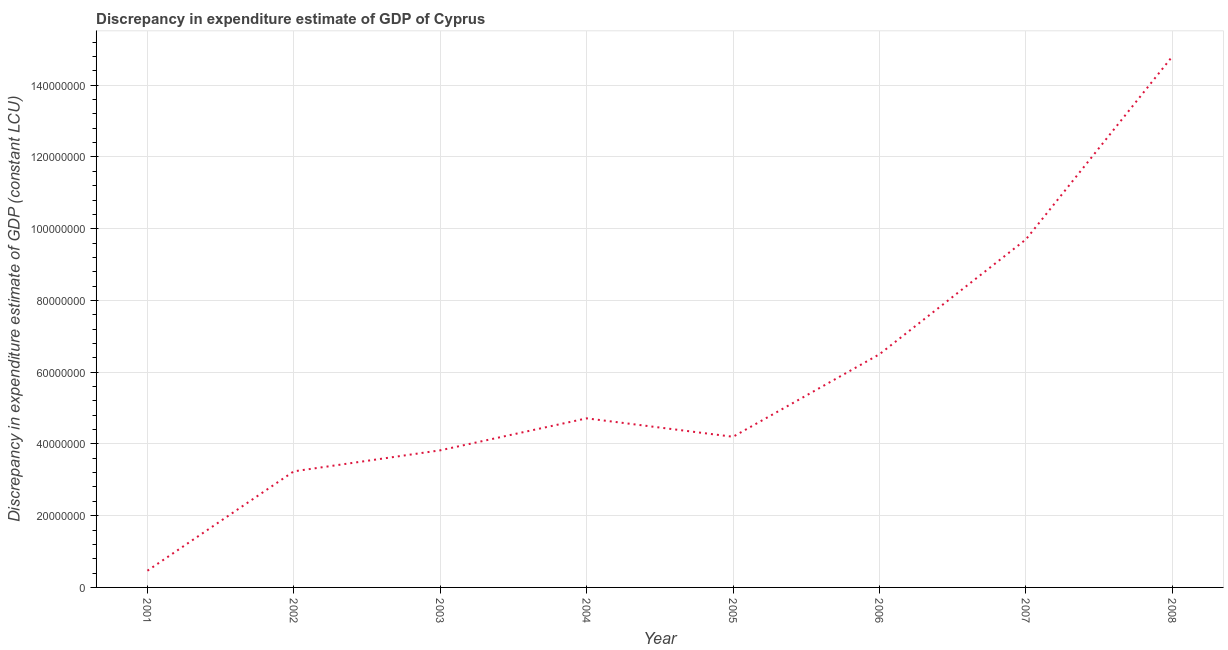What is the discrepancy in expenditure estimate of gdp in 2007?
Provide a succinct answer. 9.70e+07. Across all years, what is the maximum discrepancy in expenditure estimate of gdp?
Ensure brevity in your answer.  1.48e+08. Across all years, what is the minimum discrepancy in expenditure estimate of gdp?
Make the answer very short. 4.66e+06. What is the sum of the discrepancy in expenditure estimate of gdp?
Provide a short and direct response. 4.74e+08. What is the difference between the discrepancy in expenditure estimate of gdp in 2006 and 2007?
Provide a short and direct response. -3.20e+07. What is the average discrepancy in expenditure estimate of gdp per year?
Your response must be concise. 5.93e+07. What is the median discrepancy in expenditure estimate of gdp?
Your answer should be very brief. 4.46e+07. Do a majority of the years between 2006 and 2003 (inclusive) have discrepancy in expenditure estimate of gdp greater than 120000000 LCU?
Offer a very short reply. Yes. What is the ratio of the discrepancy in expenditure estimate of gdp in 2002 to that in 2008?
Your answer should be very brief. 0.22. Is the discrepancy in expenditure estimate of gdp in 2001 less than that in 2002?
Ensure brevity in your answer.  Yes. Is the difference between the discrepancy in expenditure estimate of gdp in 2002 and 2007 greater than the difference between any two years?
Keep it short and to the point. No. What is the difference between the highest and the second highest discrepancy in expenditure estimate of gdp?
Keep it short and to the point. 5.10e+07. Is the sum of the discrepancy in expenditure estimate of gdp in 2001 and 2006 greater than the maximum discrepancy in expenditure estimate of gdp across all years?
Ensure brevity in your answer.  No. What is the difference between the highest and the lowest discrepancy in expenditure estimate of gdp?
Keep it short and to the point. 1.43e+08. In how many years, is the discrepancy in expenditure estimate of gdp greater than the average discrepancy in expenditure estimate of gdp taken over all years?
Make the answer very short. 3. Does the discrepancy in expenditure estimate of gdp monotonically increase over the years?
Your answer should be compact. No. How many lines are there?
Your response must be concise. 1. How many years are there in the graph?
Provide a succinct answer. 8. What is the difference between two consecutive major ticks on the Y-axis?
Your response must be concise. 2.00e+07. Does the graph contain any zero values?
Ensure brevity in your answer.  No. What is the title of the graph?
Your response must be concise. Discrepancy in expenditure estimate of GDP of Cyprus. What is the label or title of the Y-axis?
Provide a short and direct response. Discrepancy in expenditure estimate of GDP (constant LCU). What is the Discrepancy in expenditure estimate of GDP (constant LCU) of 2001?
Your answer should be very brief. 4.66e+06. What is the Discrepancy in expenditure estimate of GDP (constant LCU) of 2002?
Offer a terse response. 3.24e+07. What is the Discrepancy in expenditure estimate of GDP (constant LCU) in 2003?
Provide a succinct answer. 3.82e+07. What is the Discrepancy in expenditure estimate of GDP (constant LCU) of 2004?
Your answer should be very brief. 4.71e+07. What is the Discrepancy in expenditure estimate of GDP (constant LCU) of 2005?
Offer a very short reply. 4.20e+07. What is the Discrepancy in expenditure estimate of GDP (constant LCU) in 2006?
Your answer should be very brief. 6.50e+07. What is the Discrepancy in expenditure estimate of GDP (constant LCU) of 2007?
Make the answer very short. 9.70e+07. What is the Discrepancy in expenditure estimate of GDP (constant LCU) in 2008?
Provide a succinct answer. 1.48e+08. What is the difference between the Discrepancy in expenditure estimate of GDP (constant LCU) in 2001 and 2002?
Your response must be concise. -2.77e+07. What is the difference between the Discrepancy in expenditure estimate of GDP (constant LCU) in 2001 and 2003?
Keep it short and to the point. -3.36e+07. What is the difference between the Discrepancy in expenditure estimate of GDP (constant LCU) in 2001 and 2004?
Give a very brief answer. -4.25e+07. What is the difference between the Discrepancy in expenditure estimate of GDP (constant LCU) in 2001 and 2005?
Ensure brevity in your answer.  -3.73e+07. What is the difference between the Discrepancy in expenditure estimate of GDP (constant LCU) in 2001 and 2006?
Offer a terse response. -6.03e+07. What is the difference between the Discrepancy in expenditure estimate of GDP (constant LCU) in 2001 and 2007?
Make the answer very short. -9.23e+07. What is the difference between the Discrepancy in expenditure estimate of GDP (constant LCU) in 2001 and 2008?
Offer a terse response. -1.43e+08. What is the difference between the Discrepancy in expenditure estimate of GDP (constant LCU) in 2002 and 2003?
Your answer should be very brief. -5.86e+06. What is the difference between the Discrepancy in expenditure estimate of GDP (constant LCU) in 2002 and 2004?
Your answer should be very brief. -1.48e+07. What is the difference between the Discrepancy in expenditure estimate of GDP (constant LCU) in 2002 and 2005?
Keep it short and to the point. -9.63e+06. What is the difference between the Discrepancy in expenditure estimate of GDP (constant LCU) in 2002 and 2006?
Offer a very short reply. -3.26e+07. What is the difference between the Discrepancy in expenditure estimate of GDP (constant LCU) in 2002 and 2007?
Your response must be concise. -6.46e+07. What is the difference between the Discrepancy in expenditure estimate of GDP (constant LCU) in 2002 and 2008?
Your answer should be very brief. -1.16e+08. What is the difference between the Discrepancy in expenditure estimate of GDP (constant LCU) in 2003 and 2004?
Your answer should be compact. -8.91e+06. What is the difference between the Discrepancy in expenditure estimate of GDP (constant LCU) in 2003 and 2005?
Ensure brevity in your answer.  -3.78e+06. What is the difference between the Discrepancy in expenditure estimate of GDP (constant LCU) in 2003 and 2006?
Offer a terse response. -2.68e+07. What is the difference between the Discrepancy in expenditure estimate of GDP (constant LCU) in 2003 and 2007?
Your answer should be very brief. -5.88e+07. What is the difference between the Discrepancy in expenditure estimate of GDP (constant LCU) in 2003 and 2008?
Ensure brevity in your answer.  -1.10e+08. What is the difference between the Discrepancy in expenditure estimate of GDP (constant LCU) in 2004 and 2005?
Provide a short and direct response. 5.14e+06. What is the difference between the Discrepancy in expenditure estimate of GDP (constant LCU) in 2004 and 2006?
Make the answer very short. -1.79e+07. What is the difference between the Discrepancy in expenditure estimate of GDP (constant LCU) in 2004 and 2007?
Give a very brief answer. -4.99e+07. What is the difference between the Discrepancy in expenditure estimate of GDP (constant LCU) in 2004 and 2008?
Make the answer very short. -1.01e+08. What is the difference between the Discrepancy in expenditure estimate of GDP (constant LCU) in 2005 and 2006?
Provide a succinct answer. -2.30e+07. What is the difference between the Discrepancy in expenditure estimate of GDP (constant LCU) in 2005 and 2007?
Keep it short and to the point. -5.50e+07. What is the difference between the Discrepancy in expenditure estimate of GDP (constant LCU) in 2005 and 2008?
Your answer should be very brief. -1.06e+08. What is the difference between the Discrepancy in expenditure estimate of GDP (constant LCU) in 2006 and 2007?
Ensure brevity in your answer.  -3.20e+07. What is the difference between the Discrepancy in expenditure estimate of GDP (constant LCU) in 2006 and 2008?
Your answer should be very brief. -8.30e+07. What is the difference between the Discrepancy in expenditure estimate of GDP (constant LCU) in 2007 and 2008?
Ensure brevity in your answer.  -5.10e+07. What is the ratio of the Discrepancy in expenditure estimate of GDP (constant LCU) in 2001 to that in 2002?
Provide a short and direct response. 0.14. What is the ratio of the Discrepancy in expenditure estimate of GDP (constant LCU) in 2001 to that in 2003?
Your answer should be very brief. 0.12. What is the ratio of the Discrepancy in expenditure estimate of GDP (constant LCU) in 2001 to that in 2004?
Your answer should be compact. 0.1. What is the ratio of the Discrepancy in expenditure estimate of GDP (constant LCU) in 2001 to that in 2005?
Give a very brief answer. 0.11. What is the ratio of the Discrepancy in expenditure estimate of GDP (constant LCU) in 2001 to that in 2006?
Your response must be concise. 0.07. What is the ratio of the Discrepancy in expenditure estimate of GDP (constant LCU) in 2001 to that in 2007?
Ensure brevity in your answer.  0.05. What is the ratio of the Discrepancy in expenditure estimate of GDP (constant LCU) in 2001 to that in 2008?
Make the answer very short. 0.03. What is the ratio of the Discrepancy in expenditure estimate of GDP (constant LCU) in 2002 to that in 2003?
Make the answer very short. 0.85. What is the ratio of the Discrepancy in expenditure estimate of GDP (constant LCU) in 2002 to that in 2004?
Give a very brief answer. 0.69. What is the ratio of the Discrepancy in expenditure estimate of GDP (constant LCU) in 2002 to that in 2005?
Provide a short and direct response. 0.77. What is the ratio of the Discrepancy in expenditure estimate of GDP (constant LCU) in 2002 to that in 2006?
Provide a short and direct response. 0.5. What is the ratio of the Discrepancy in expenditure estimate of GDP (constant LCU) in 2002 to that in 2007?
Ensure brevity in your answer.  0.33. What is the ratio of the Discrepancy in expenditure estimate of GDP (constant LCU) in 2002 to that in 2008?
Your answer should be very brief. 0.22. What is the ratio of the Discrepancy in expenditure estimate of GDP (constant LCU) in 2003 to that in 2004?
Ensure brevity in your answer.  0.81. What is the ratio of the Discrepancy in expenditure estimate of GDP (constant LCU) in 2003 to that in 2005?
Offer a very short reply. 0.91. What is the ratio of the Discrepancy in expenditure estimate of GDP (constant LCU) in 2003 to that in 2006?
Offer a very short reply. 0.59. What is the ratio of the Discrepancy in expenditure estimate of GDP (constant LCU) in 2003 to that in 2007?
Provide a short and direct response. 0.39. What is the ratio of the Discrepancy in expenditure estimate of GDP (constant LCU) in 2003 to that in 2008?
Make the answer very short. 0.26. What is the ratio of the Discrepancy in expenditure estimate of GDP (constant LCU) in 2004 to that in 2005?
Offer a very short reply. 1.12. What is the ratio of the Discrepancy in expenditure estimate of GDP (constant LCU) in 2004 to that in 2006?
Ensure brevity in your answer.  0.72. What is the ratio of the Discrepancy in expenditure estimate of GDP (constant LCU) in 2004 to that in 2007?
Provide a short and direct response. 0.49. What is the ratio of the Discrepancy in expenditure estimate of GDP (constant LCU) in 2004 to that in 2008?
Provide a succinct answer. 0.32. What is the ratio of the Discrepancy in expenditure estimate of GDP (constant LCU) in 2005 to that in 2006?
Give a very brief answer. 0.65. What is the ratio of the Discrepancy in expenditure estimate of GDP (constant LCU) in 2005 to that in 2007?
Your response must be concise. 0.43. What is the ratio of the Discrepancy in expenditure estimate of GDP (constant LCU) in 2005 to that in 2008?
Provide a short and direct response. 0.28. What is the ratio of the Discrepancy in expenditure estimate of GDP (constant LCU) in 2006 to that in 2007?
Make the answer very short. 0.67. What is the ratio of the Discrepancy in expenditure estimate of GDP (constant LCU) in 2006 to that in 2008?
Your response must be concise. 0.44. What is the ratio of the Discrepancy in expenditure estimate of GDP (constant LCU) in 2007 to that in 2008?
Give a very brief answer. 0.66. 